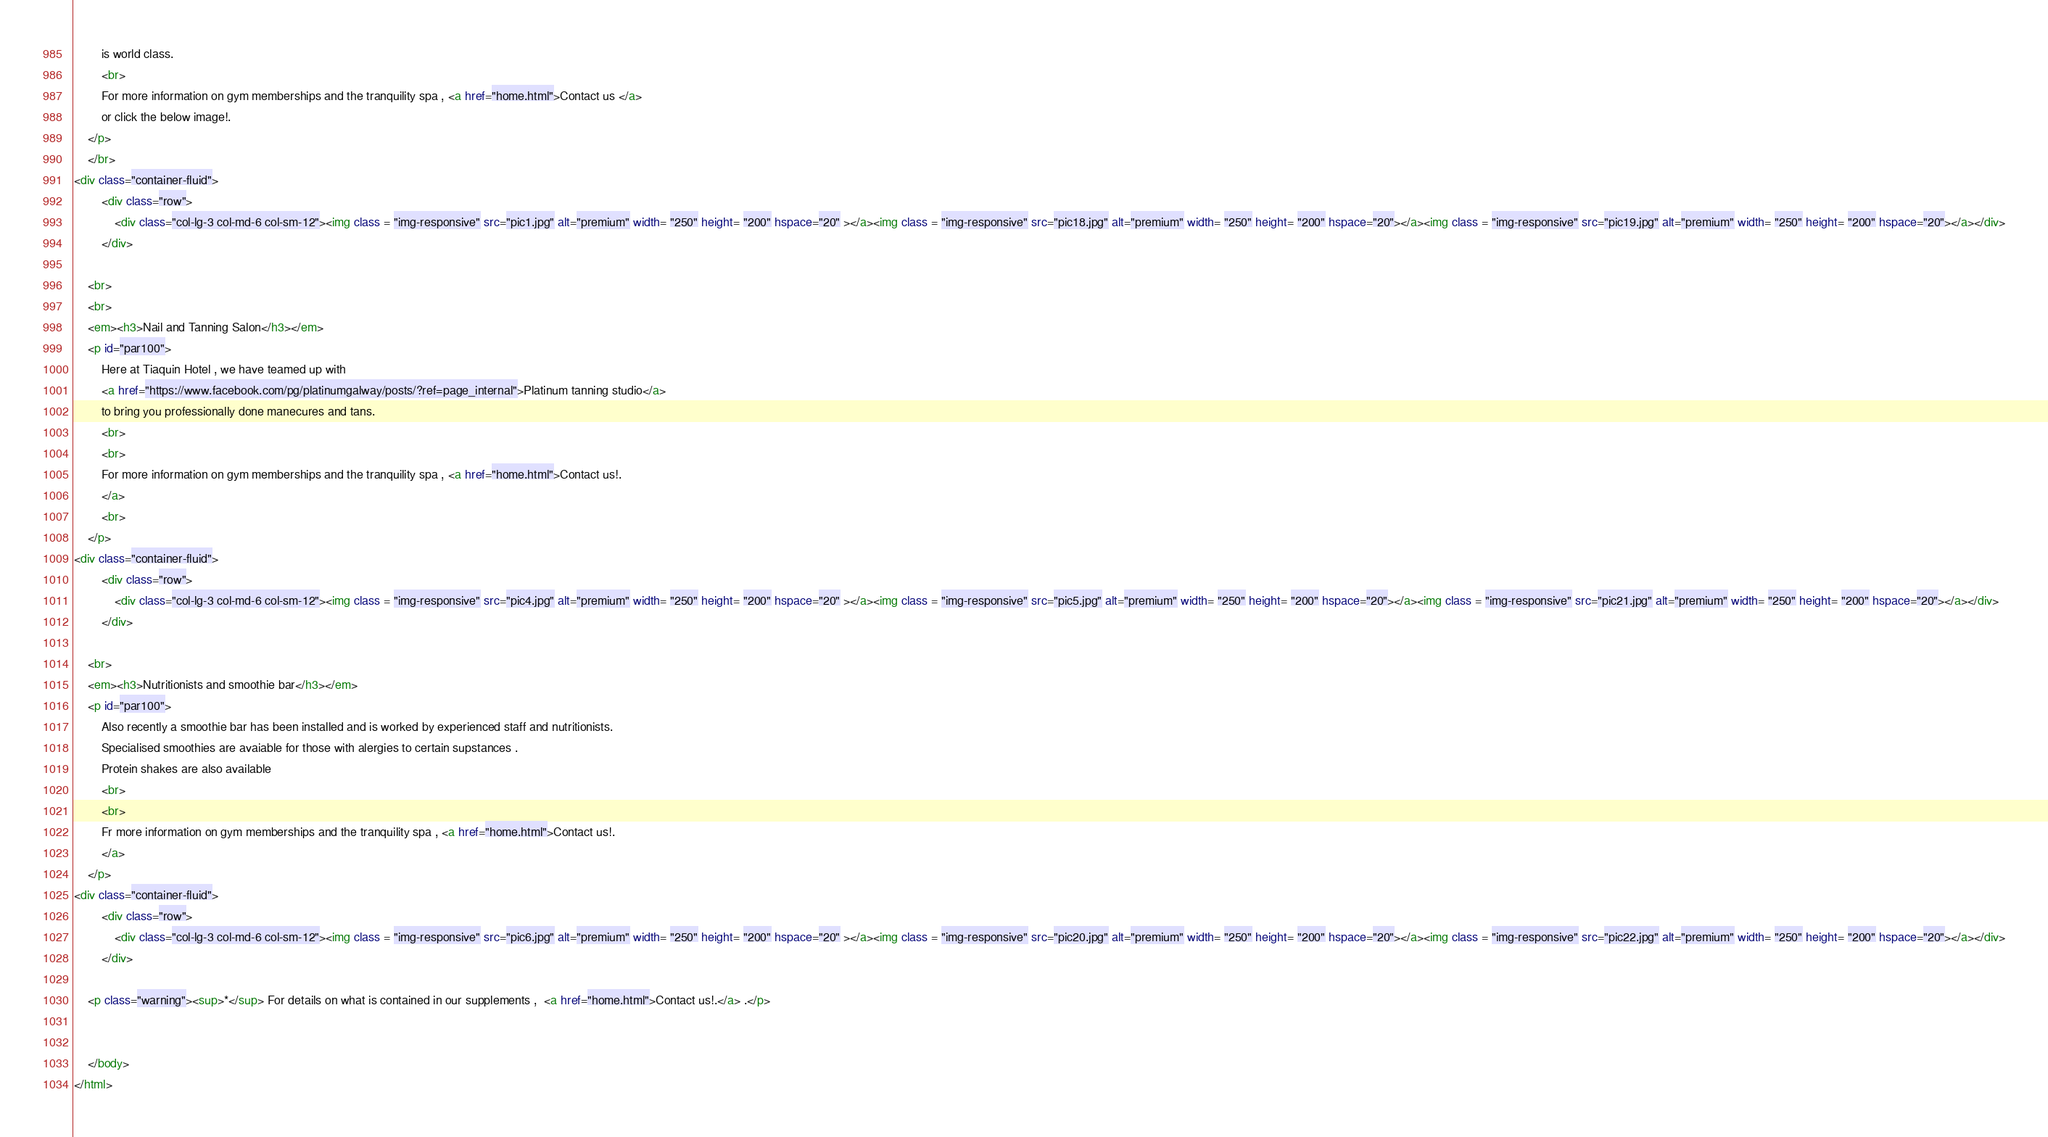<code> <loc_0><loc_0><loc_500><loc_500><_HTML_>		is world class.
		<br>
		For more information on gym memberships and the tranquility spa , <a href="home.html">Contact us </a>
		or click the below image!.
	</p>
	</br>
<div class="container-fluid">
        <div class="row">
            <div class="col-lg-3 col-md-6 col-sm-12"><img class = "img-responsive" src="pic1.jpg" alt="premium" width= "250" height= "200" hspace="20" ></a><img class = "img-responsive" src="pic18.jpg" alt="premium" width= "250" height= "200" hspace="20"></a><img class = "img-responsive" src="pic19.jpg" alt="premium" width= "250" height= "200" hspace="20"></a></div>
        </div>	

	<br>
	<br>
	<em><h3>Nail and Tanning Salon</h3></em>
	<p id="par100">
		Here at Tiaquin Hotel , we have teamed up with
		<a href="https://www.facebook.com/pg/platinumgalway/posts/?ref=page_internal">Platinum tanning studio</a>
		to bring you professionally done manecures and tans.
		<br>
		<br>
		For more information on gym memberships and the tranquility spa , <a href="home.html">Contact us!.
		</a>
		<br>
	</p>
<div class="container-fluid">
        <div class="row">
            <div class="col-lg-3 col-md-6 col-sm-12"><img class = "img-responsive" src="pic4.jpg" alt="premium" width= "250" height= "200" hspace="20" ></a><img class = "img-responsive" src="pic5.jpg" alt="premium" width= "250" height= "200" hspace="20"></a><img class = "img-responsive" src="pic21.jpg" alt="premium" width= "250" height= "200" hspace="20"></a></div>
        </div>		

	<br>
	<em><h3>Nutritionists and smoothie bar</h3></em>
	<p id="par100">
		Also recently a smoothie bar has been installed and is worked by experienced staff and nutritionists.
		Specialised smoothies are avaiable for those with alergies to certain supstances .
		Protein shakes are also available
		<br>
		<br>
		Fr more information on gym memberships and the tranquility spa , <a href="home.html">Contact us!.
		</a>		
	</p>
<div class="container-fluid">
        <div class="row">
            <div class="col-lg-3 col-md-6 col-sm-12"><img class = "img-responsive" src="pic6.jpg" alt="premium" width= "250" height= "200" hspace="20" ></a><img class = "img-responsive" src="pic20.jpg" alt="premium" width= "250" height= "200" hspace="20"></a><img class = "img-responsive" src="pic22.jpg" alt="premium" width= "250" height= "200" hspace="20"></a></div>
        </div>		

	<p class="warning"><sup>*</sup> For details on what is contained in our supplements ,  <a href="home.html">Contact us!.</a> .</p>
	
	
	</body>
</html></code> 